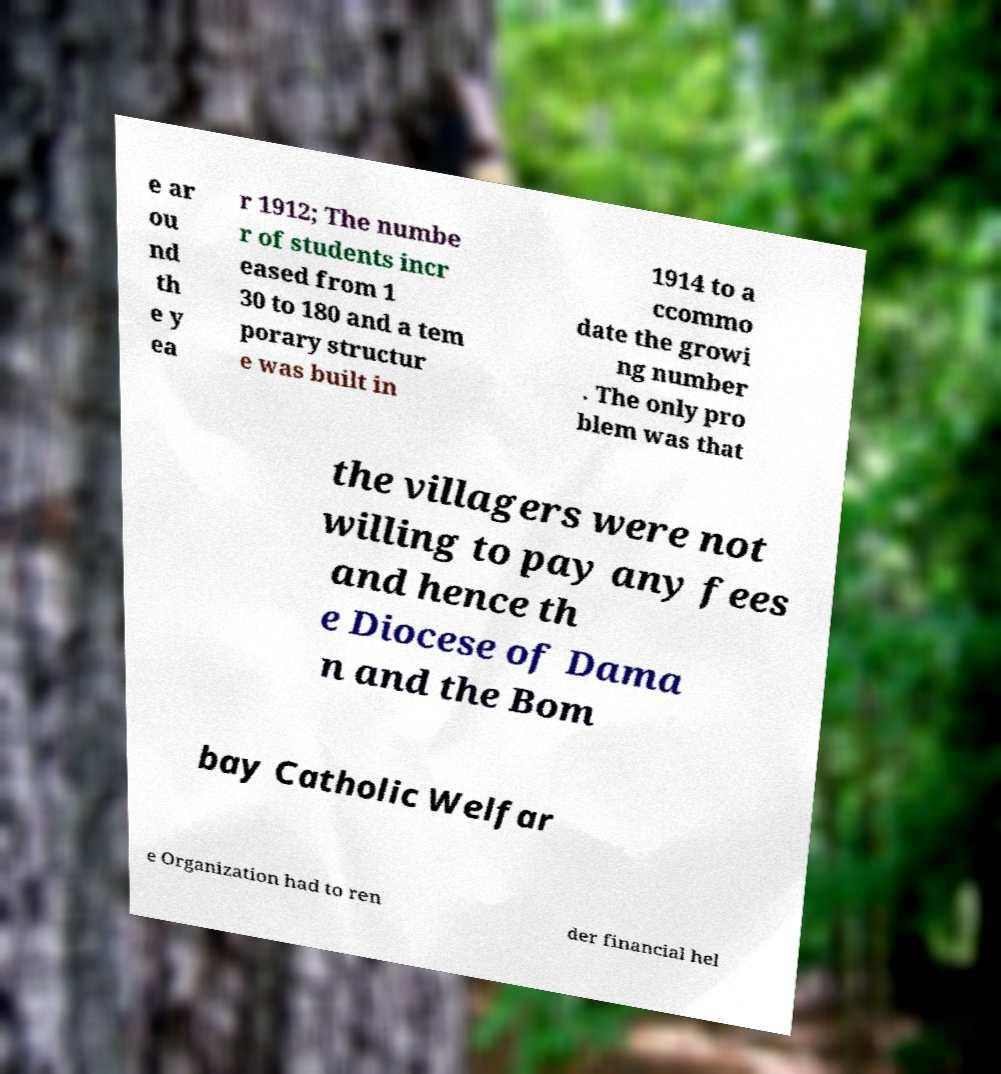Please read and relay the text visible in this image. What does it say? e ar ou nd th e y ea r 1912; The numbe r of students incr eased from 1 30 to 180 and a tem porary structur e was built in 1914 to a ccommo date the growi ng number . The only pro blem was that the villagers were not willing to pay any fees and hence th e Diocese of Dama n and the Bom bay Catholic Welfar e Organization had to ren der financial hel 